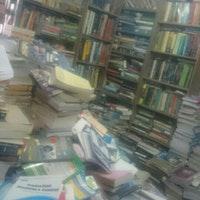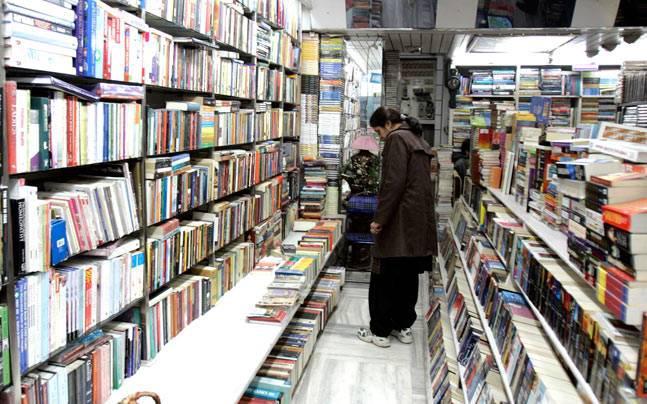The first image is the image on the left, the second image is the image on the right. Analyze the images presented: Is the assertion "In one image there is at least one person standing in a book store in the center of the image." valid? Answer yes or no. Yes. The first image is the image on the left, the second image is the image on the right. Analyze the images presented: Is the assertion "One image has a man facing left and looking down." valid? Answer yes or no. No. 